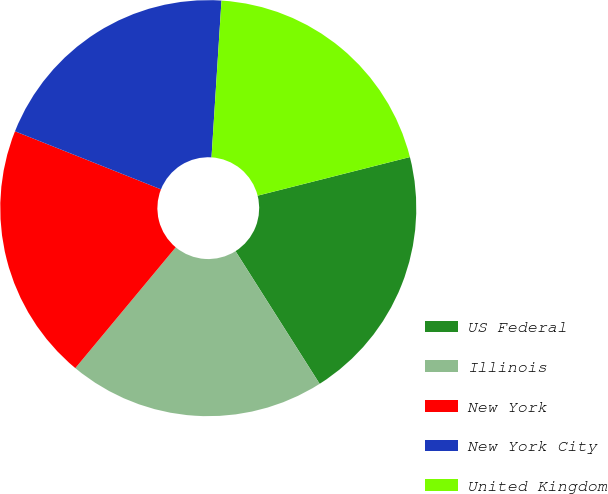Convert chart. <chart><loc_0><loc_0><loc_500><loc_500><pie_chart><fcel>US Federal<fcel>Illinois<fcel>New York<fcel>New York City<fcel>United Kingdom<nl><fcel>19.96%<fcel>20.03%<fcel>19.99%<fcel>19.99%<fcel>20.04%<nl></chart> 